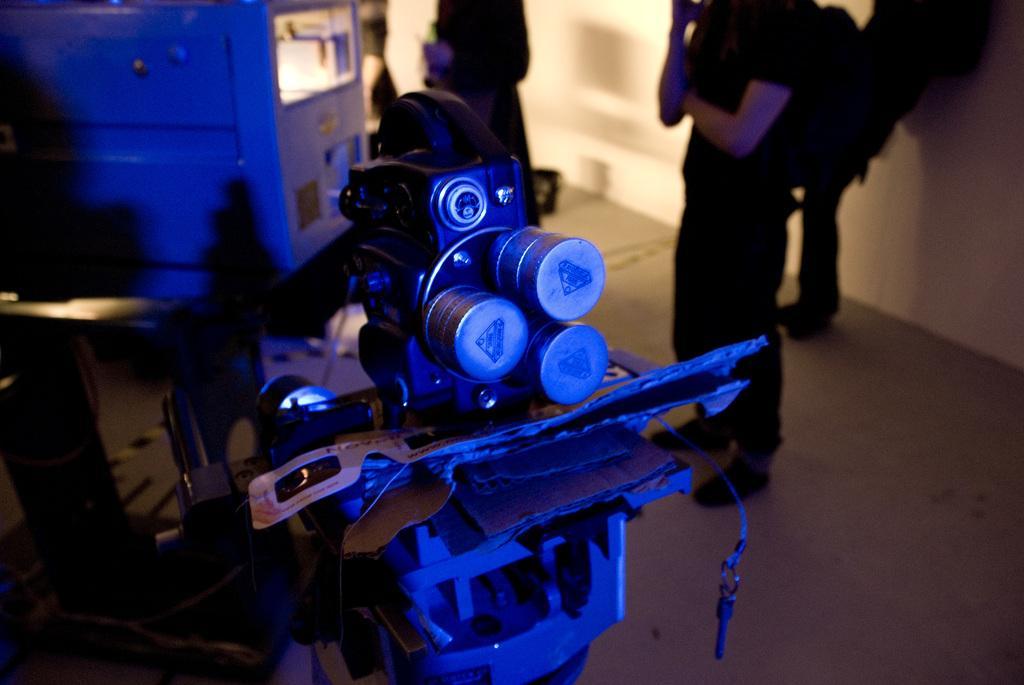In one or two sentences, can you explain what this image depicts? On the right side, there are persons standing on the floor. In front of them, there are machines. In the background, there is wall. 